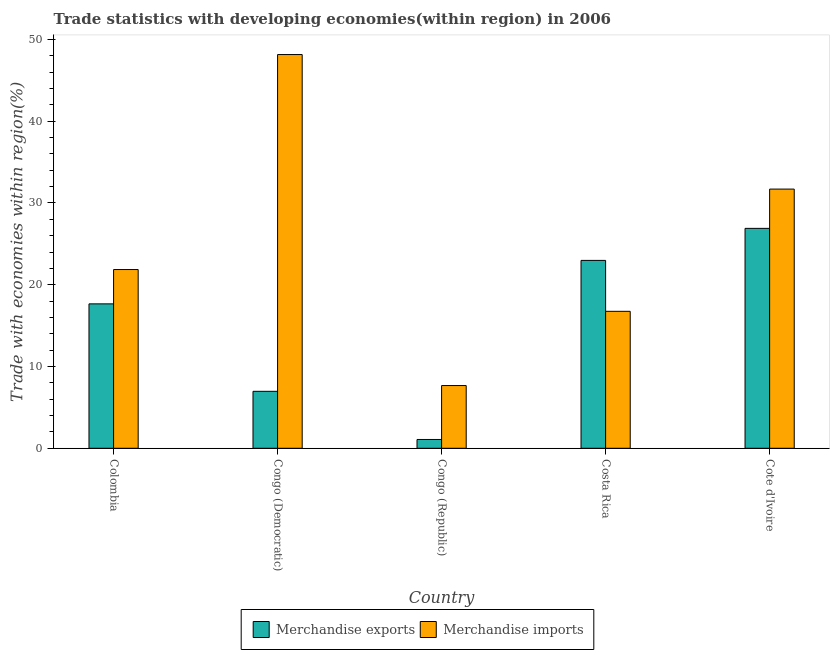How many groups of bars are there?
Offer a terse response. 5. How many bars are there on the 3rd tick from the left?
Offer a terse response. 2. What is the label of the 5th group of bars from the left?
Your response must be concise. Cote d'Ivoire. What is the merchandise exports in Costa Rica?
Offer a terse response. 22.98. Across all countries, what is the maximum merchandise exports?
Make the answer very short. 26.89. Across all countries, what is the minimum merchandise exports?
Give a very brief answer. 1.08. In which country was the merchandise exports maximum?
Offer a terse response. Cote d'Ivoire. In which country was the merchandise imports minimum?
Keep it short and to the point. Congo (Republic). What is the total merchandise exports in the graph?
Offer a very short reply. 75.57. What is the difference between the merchandise imports in Colombia and that in Costa Rica?
Keep it short and to the point. 5.11. What is the difference between the merchandise imports in Congo (Republic) and the merchandise exports in Cote d'Ivoire?
Offer a very short reply. -19.22. What is the average merchandise imports per country?
Provide a succinct answer. 25.22. What is the difference between the merchandise imports and merchandise exports in Costa Rica?
Your response must be concise. -6.23. In how many countries, is the merchandise imports greater than 46 %?
Offer a terse response. 1. What is the ratio of the merchandise imports in Costa Rica to that in Cote d'Ivoire?
Your answer should be very brief. 0.53. Is the difference between the merchandise imports in Congo (Republic) and Costa Rica greater than the difference between the merchandise exports in Congo (Republic) and Costa Rica?
Offer a terse response. Yes. What is the difference between the highest and the second highest merchandise exports?
Your answer should be compact. 3.92. What is the difference between the highest and the lowest merchandise imports?
Provide a succinct answer. 40.48. Is the sum of the merchandise imports in Colombia and Congo (Republic) greater than the maximum merchandise exports across all countries?
Ensure brevity in your answer.  Yes. Are all the bars in the graph horizontal?
Provide a short and direct response. No. How many countries are there in the graph?
Provide a short and direct response. 5. Where does the legend appear in the graph?
Make the answer very short. Bottom center. How are the legend labels stacked?
Your response must be concise. Horizontal. What is the title of the graph?
Ensure brevity in your answer.  Trade statistics with developing economies(within region) in 2006. What is the label or title of the X-axis?
Make the answer very short. Country. What is the label or title of the Y-axis?
Give a very brief answer. Trade with economies within region(%). What is the Trade with economies within region(%) of Merchandise exports in Colombia?
Offer a very short reply. 17.66. What is the Trade with economies within region(%) of Merchandise imports in Colombia?
Provide a short and direct response. 21.86. What is the Trade with economies within region(%) in Merchandise exports in Congo (Democratic)?
Make the answer very short. 6.96. What is the Trade with economies within region(%) of Merchandise imports in Congo (Democratic)?
Give a very brief answer. 48.15. What is the Trade with economies within region(%) in Merchandise exports in Congo (Republic)?
Make the answer very short. 1.08. What is the Trade with economies within region(%) of Merchandise imports in Congo (Republic)?
Provide a succinct answer. 7.67. What is the Trade with economies within region(%) of Merchandise exports in Costa Rica?
Give a very brief answer. 22.98. What is the Trade with economies within region(%) of Merchandise imports in Costa Rica?
Offer a very short reply. 16.75. What is the Trade with economies within region(%) of Merchandise exports in Cote d'Ivoire?
Offer a very short reply. 26.89. What is the Trade with economies within region(%) in Merchandise imports in Cote d'Ivoire?
Your answer should be compact. 31.7. Across all countries, what is the maximum Trade with economies within region(%) in Merchandise exports?
Provide a short and direct response. 26.89. Across all countries, what is the maximum Trade with economies within region(%) of Merchandise imports?
Provide a short and direct response. 48.15. Across all countries, what is the minimum Trade with economies within region(%) of Merchandise exports?
Ensure brevity in your answer.  1.08. Across all countries, what is the minimum Trade with economies within region(%) of Merchandise imports?
Keep it short and to the point. 7.67. What is the total Trade with economies within region(%) in Merchandise exports in the graph?
Your answer should be compact. 75.57. What is the total Trade with economies within region(%) of Merchandise imports in the graph?
Your answer should be very brief. 126.12. What is the difference between the Trade with economies within region(%) of Merchandise exports in Colombia and that in Congo (Democratic)?
Offer a very short reply. 10.69. What is the difference between the Trade with economies within region(%) of Merchandise imports in Colombia and that in Congo (Democratic)?
Your answer should be compact. -26.29. What is the difference between the Trade with economies within region(%) in Merchandise exports in Colombia and that in Congo (Republic)?
Provide a succinct answer. 16.58. What is the difference between the Trade with economies within region(%) in Merchandise imports in Colombia and that in Congo (Republic)?
Offer a terse response. 14.19. What is the difference between the Trade with economies within region(%) of Merchandise exports in Colombia and that in Costa Rica?
Keep it short and to the point. -5.32. What is the difference between the Trade with economies within region(%) in Merchandise imports in Colombia and that in Costa Rica?
Your answer should be very brief. 5.11. What is the difference between the Trade with economies within region(%) in Merchandise exports in Colombia and that in Cote d'Ivoire?
Give a very brief answer. -9.23. What is the difference between the Trade with economies within region(%) in Merchandise imports in Colombia and that in Cote d'Ivoire?
Your answer should be compact. -9.84. What is the difference between the Trade with economies within region(%) in Merchandise exports in Congo (Democratic) and that in Congo (Republic)?
Your answer should be very brief. 5.89. What is the difference between the Trade with economies within region(%) in Merchandise imports in Congo (Democratic) and that in Congo (Republic)?
Your answer should be compact. 40.48. What is the difference between the Trade with economies within region(%) of Merchandise exports in Congo (Democratic) and that in Costa Rica?
Your response must be concise. -16.01. What is the difference between the Trade with economies within region(%) of Merchandise imports in Congo (Democratic) and that in Costa Rica?
Your response must be concise. 31.4. What is the difference between the Trade with economies within region(%) in Merchandise exports in Congo (Democratic) and that in Cote d'Ivoire?
Offer a terse response. -19.93. What is the difference between the Trade with economies within region(%) of Merchandise imports in Congo (Democratic) and that in Cote d'Ivoire?
Your answer should be very brief. 16.45. What is the difference between the Trade with economies within region(%) in Merchandise exports in Congo (Republic) and that in Costa Rica?
Your answer should be compact. -21.9. What is the difference between the Trade with economies within region(%) in Merchandise imports in Congo (Republic) and that in Costa Rica?
Ensure brevity in your answer.  -9.08. What is the difference between the Trade with economies within region(%) of Merchandise exports in Congo (Republic) and that in Cote d'Ivoire?
Offer a terse response. -25.82. What is the difference between the Trade with economies within region(%) in Merchandise imports in Congo (Republic) and that in Cote d'Ivoire?
Your answer should be very brief. -24.02. What is the difference between the Trade with economies within region(%) of Merchandise exports in Costa Rica and that in Cote d'Ivoire?
Your answer should be compact. -3.92. What is the difference between the Trade with economies within region(%) of Merchandise imports in Costa Rica and that in Cote d'Ivoire?
Your answer should be very brief. -14.95. What is the difference between the Trade with economies within region(%) in Merchandise exports in Colombia and the Trade with economies within region(%) in Merchandise imports in Congo (Democratic)?
Provide a succinct answer. -30.49. What is the difference between the Trade with economies within region(%) in Merchandise exports in Colombia and the Trade with economies within region(%) in Merchandise imports in Congo (Republic)?
Provide a short and direct response. 9.99. What is the difference between the Trade with economies within region(%) in Merchandise exports in Colombia and the Trade with economies within region(%) in Merchandise imports in Costa Rica?
Make the answer very short. 0.91. What is the difference between the Trade with economies within region(%) of Merchandise exports in Colombia and the Trade with economies within region(%) of Merchandise imports in Cote d'Ivoire?
Ensure brevity in your answer.  -14.04. What is the difference between the Trade with economies within region(%) in Merchandise exports in Congo (Democratic) and the Trade with economies within region(%) in Merchandise imports in Congo (Republic)?
Offer a very short reply. -0.71. What is the difference between the Trade with economies within region(%) of Merchandise exports in Congo (Democratic) and the Trade with economies within region(%) of Merchandise imports in Costa Rica?
Make the answer very short. -9.78. What is the difference between the Trade with economies within region(%) in Merchandise exports in Congo (Democratic) and the Trade with economies within region(%) in Merchandise imports in Cote d'Ivoire?
Provide a short and direct response. -24.73. What is the difference between the Trade with economies within region(%) in Merchandise exports in Congo (Republic) and the Trade with economies within region(%) in Merchandise imports in Costa Rica?
Offer a terse response. -15.67. What is the difference between the Trade with economies within region(%) of Merchandise exports in Congo (Republic) and the Trade with economies within region(%) of Merchandise imports in Cote d'Ivoire?
Make the answer very short. -30.62. What is the difference between the Trade with economies within region(%) of Merchandise exports in Costa Rica and the Trade with economies within region(%) of Merchandise imports in Cote d'Ivoire?
Provide a succinct answer. -8.72. What is the average Trade with economies within region(%) of Merchandise exports per country?
Make the answer very short. 15.11. What is the average Trade with economies within region(%) of Merchandise imports per country?
Your answer should be very brief. 25.22. What is the difference between the Trade with economies within region(%) in Merchandise exports and Trade with economies within region(%) in Merchandise imports in Colombia?
Offer a terse response. -4.2. What is the difference between the Trade with economies within region(%) in Merchandise exports and Trade with economies within region(%) in Merchandise imports in Congo (Democratic)?
Offer a very short reply. -41.18. What is the difference between the Trade with economies within region(%) in Merchandise exports and Trade with economies within region(%) in Merchandise imports in Congo (Republic)?
Offer a very short reply. -6.59. What is the difference between the Trade with economies within region(%) of Merchandise exports and Trade with economies within region(%) of Merchandise imports in Costa Rica?
Provide a succinct answer. 6.23. What is the difference between the Trade with economies within region(%) of Merchandise exports and Trade with economies within region(%) of Merchandise imports in Cote d'Ivoire?
Give a very brief answer. -4.8. What is the ratio of the Trade with economies within region(%) in Merchandise exports in Colombia to that in Congo (Democratic)?
Ensure brevity in your answer.  2.54. What is the ratio of the Trade with economies within region(%) in Merchandise imports in Colombia to that in Congo (Democratic)?
Ensure brevity in your answer.  0.45. What is the ratio of the Trade with economies within region(%) of Merchandise exports in Colombia to that in Congo (Republic)?
Keep it short and to the point. 16.39. What is the ratio of the Trade with economies within region(%) in Merchandise imports in Colombia to that in Congo (Republic)?
Your answer should be compact. 2.85. What is the ratio of the Trade with economies within region(%) in Merchandise exports in Colombia to that in Costa Rica?
Provide a succinct answer. 0.77. What is the ratio of the Trade with economies within region(%) of Merchandise imports in Colombia to that in Costa Rica?
Provide a short and direct response. 1.31. What is the ratio of the Trade with economies within region(%) of Merchandise exports in Colombia to that in Cote d'Ivoire?
Provide a short and direct response. 0.66. What is the ratio of the Trade with economies within region(%) in Merchandise imports in Colombia to that in Cote d'Ivoire?
Give a very brief answer. 0.69. What is the ratio of the Trade with economies within region(%) in Merchandise exports in Congo (Democratic) to that in Congo (Republic)?
Make the answer very short. 6.47. What is the ratio of the Trade with economies within region(%) of Merchandise imports in Congo (Democratic) to that in Congo (Republic)?
Your answer should be very brief. 6.28. What is the ratio of the Trade with economies within region(%) of Merchandise exports in Congo (Democratic) to that in Costa Rica?
Your response must be concise. 0.3. What is the ratio of the Trade with economies within region(%) of Merchandise imports in Congo (Democratic) to that in Costa Rica?
Provide a succinct answer. 2.87. What is the ratio of the Trade with economies within region(%) of Merchandise exports in Congo (Democratic) to that in Cote d'Ivoire?
Provide a short and direct response. 0.26. What is the ratio of the Trade with economies within region(%) in Merchandise imports in Congo (Democratic) to that in Cote d'Ivoire?
Your answer should be compact. 1.52. What is the ratio of the Trade with economies within region(%) in Merchandise exports in Congo (Republic) to that in Costa Rica?
Provide a succinct answer. 0.05. What is the ratio of the Trade with economies within region(%) of Merchandise imports in Congo (Republic) to that in Costa Rica?
Provide a succinct answer. 0.46. What is the ratio of the Trade with economies within region(%) of Merchandise exports in Congo (Republic) to that in Cote d'Ivoire?
Offer a terse response. 0.04. What is the ratio of the Trade with economies within region(%) of Merchandise imports in Congo (Republic) to that in Cote d'Ivoire?
Ensure brevity in your answer.  0.24. What is the ratio of the Trade with economies within region(%) in Merchandise exports in Costa Rica to that in Cote d'Ivoire?
Keep it short and to the point. 0.85. What is the ratio of the Trade with economies within region(%) in Merchandise imports in Costa Rica to that in Cote d'Ivoire?
Your answer should be compact. 0.53. What is the difference between the highest and the second highest Trade with economies within region(%) of Merchandise exports?
Provide a short and direct response. 3.92. What is the difference between the highest and the second highest Trade with economies within region(%) of Merchandise imports?
Keep it short and to the point. 16.45. What is the difference between the highest and the lowest Trade with economies within region(%) in Merchandise exports?
Provide a succinct answer. 25.82. What is the difference between the highest and the lowest Trade with economies within region(%) in Merchandise imports?
Ensure brevity in your answer.  40.48. 